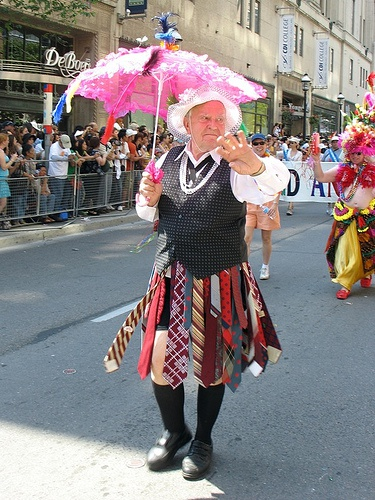Describe the objects in this image and their specific colors. I can see people in gray, black, white, and maroon tones, umbrella in gray, lavender, violet, and lightpink tones, people in gray, black, and darkgray tones, people in gray, brown, maroon, and black tones, and tie in gray, maroon, darkgray, black, and lightpink tones in this image. 